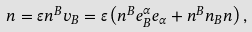<formula> <loc_0><loc_0><loc_500><loc_500>n = \varepsilon n ^ { B } v _ { B } = \varepsilon \left ( n ^ { B } e _ { B } ^ { \alpha } e _ { \alpha } + n ^ { B } n _ { B } n \right ) ,</formula> 